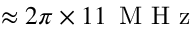<formula> <loc_0><loc_0><loc_500><loc_500>\approx 2 \pi \times 1 1 \, M H z</formula> 